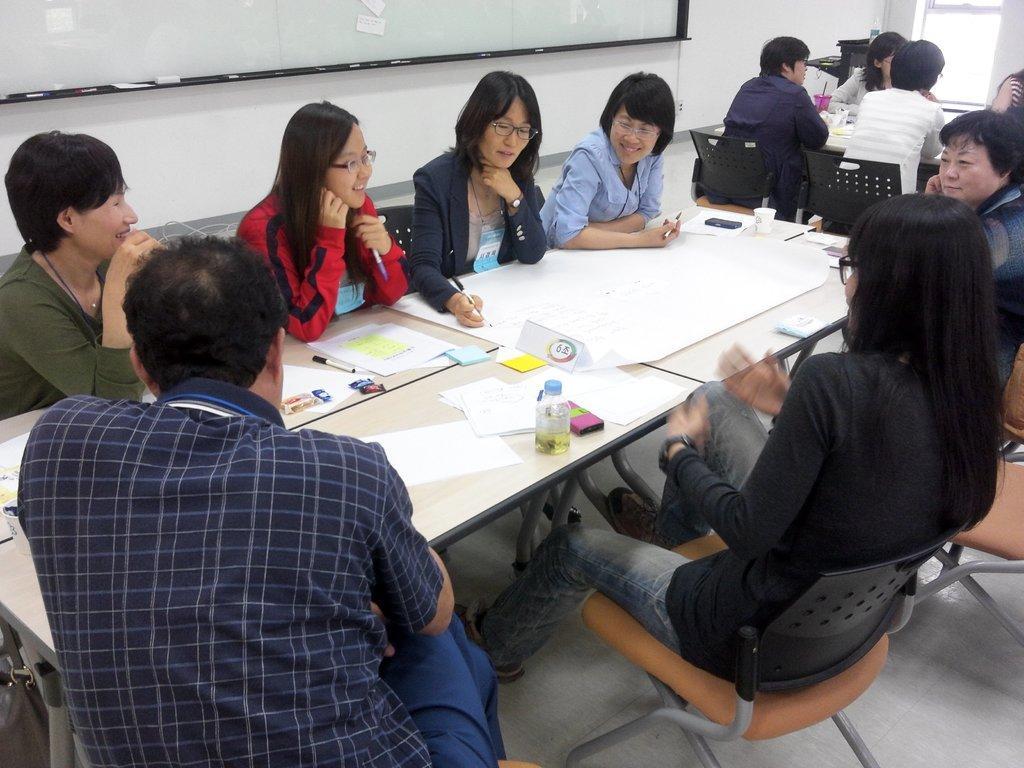How would you summarize this image in a sentence or two? In this picture we can see some persons are sitting on the chairs. This is table. On the table there are papers and a bottle. This is floor. 